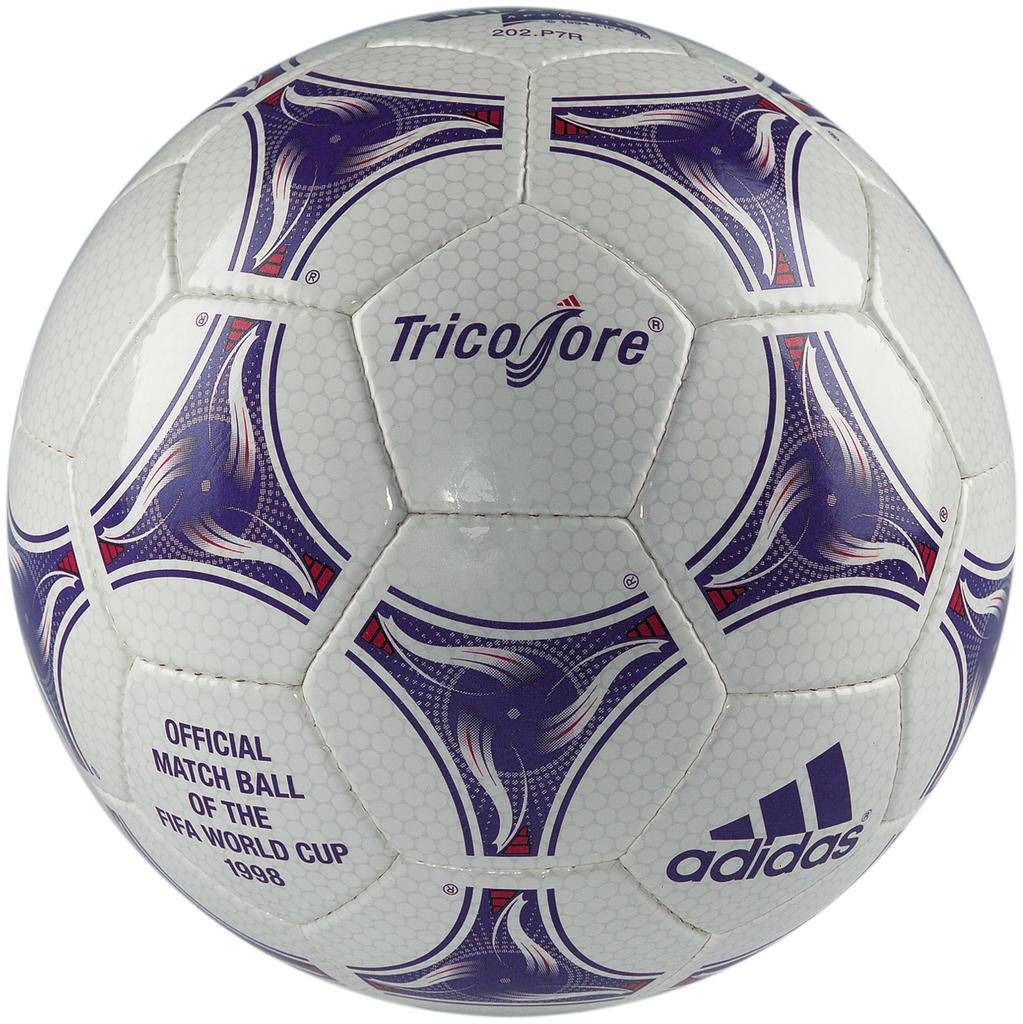What is the main object in the image? There is a football in the image. What can be seen on the surface of the football? There is something written on the football and a logo on it. What is the color of the background in the image? The background of the image is white. What type of stocking is hanging on the football in the image? There is no stocking present in the image; it only features a football with writing and a logo. 